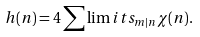Convert formula to latex. <formula><loc_0><loc_0><loc_500><loc_500>h ( n ) = 4 \sum \lim i t s _ { m | n } \chi ( n ) .</formula> 